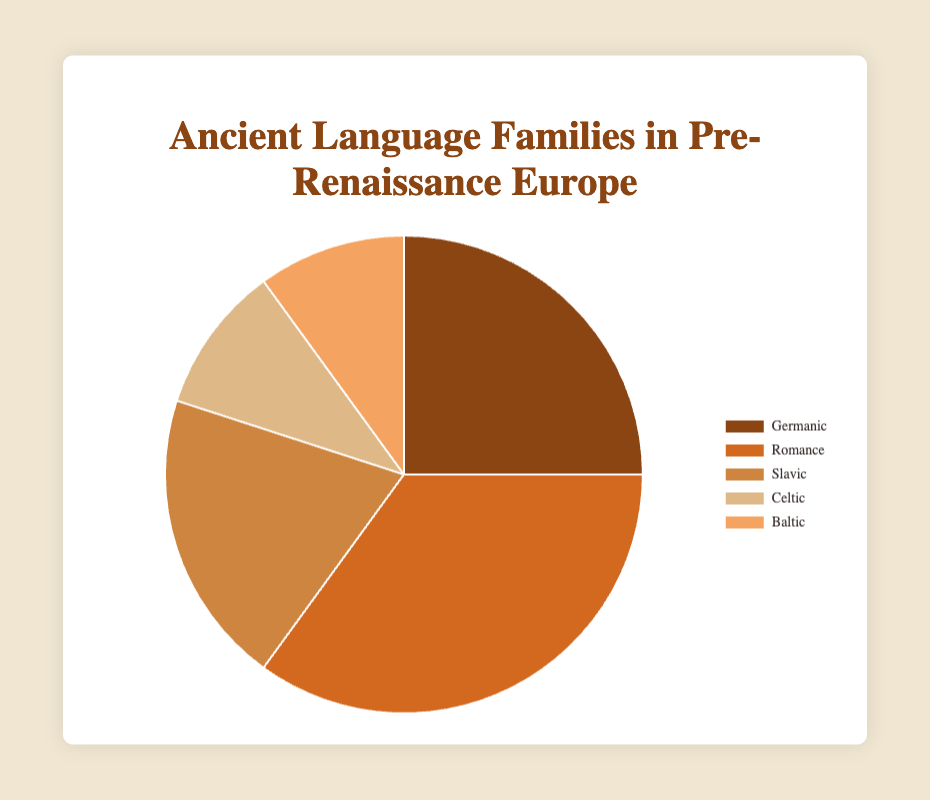What is the largest language family in Pre-Renaissance Europe according to the pie chart? The largest slice of the pie chart represents the largest language family. By looking at the sizes of the slices, we can see that the Romance language family has the largest slice, encompassing 35%.
Answer: Romance Which language families have an equal percentage representation in the pie chart? To determine which language families have equal representation, we look at the size of the slices and their corresponding percentages. The Celtic and Baltic language families both have a 10% representation.
Answer: Celtic and Baltic How much larger is the Romance language family compared to the Germanic language family? The percentages of the Romance and Germanic language families are 35% and 25% respectively. Subtracting these values gives \(35\% - 25\% = 10\%\).
Answer: 10% What is the combined percentage of the Germanic, Slavic, Celtic, and Baltic language families? Adding the percentages for the Germanic (25%), Slavic (20%), Celtic (10%), and Baltic (10%) language families yields \(25\% + 20\% + 10\% + 10\% = 65\%\).
Answer: 65% Which language family is represented by the brownish color in the pie chart? Observing the colors in the pie chart, the Germanic language family is represented by a brownish color.
Answer: Germanic Is the Slavic language family more dominant than the Celtic and Baltic families combined? The Slavic language family comprises 20%, while the Celtic and Baltic families combined total \(10\% + 10\% = 20\%\). Since both values are equal, the Slavic language family is not more dominant but rather equal in representation.
Answer: No, they are equal What is the average percentage of all language families? The percentages are: Germanic (25%), Romance (35%), Slavic (20%), Celtic (10%), and Baltic (10%). Summing these gives \(25\% + 35\% + 20\% + 10\% + 10\% = 100\%\). Dividing by the number of language families (5) gives \(100\% / 5 = 20\%\).
Answer: 20% Which language family has a 5% higher representation than the Slavic language family? The Slavic language family is represented by 20%. Adding 5% to this value gives \(20\% + 5\% = 25\%\), which corresponds to the Germanic language family.
Answer: Germanic Which language family has a percentage that matches the average percentage of all language families? The average percentage of all language families is 20%. The Slavic language family is the only one with a 20% representation, which matches the average.
Answer: Slavic 